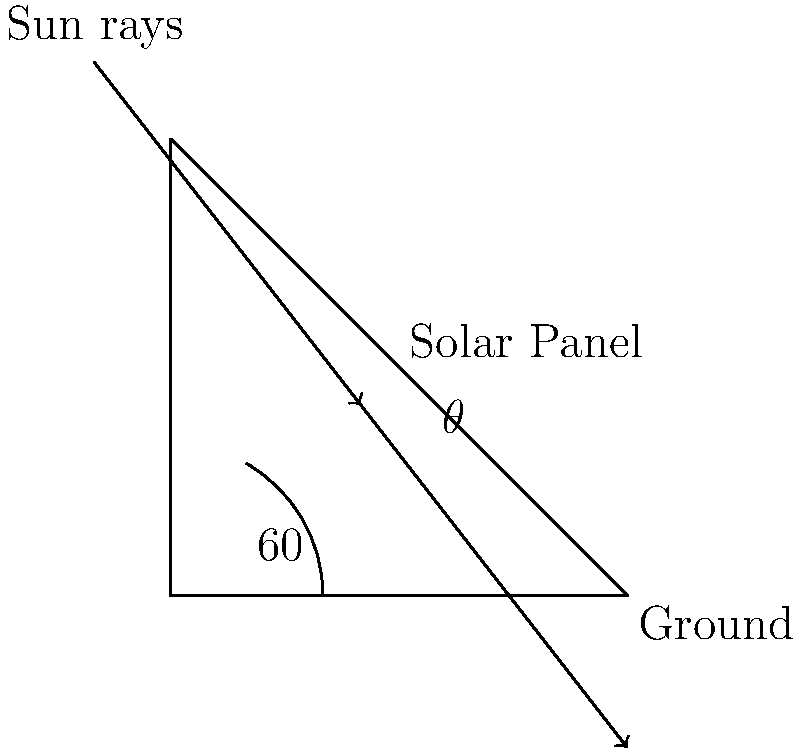In Tashkent, Uzbekistan, the average solar elevation angle during peak sunlight hours is approximately 60°. To maximize energy efficiency, solar panels should be installed perpendicular to the sun's rays. What angle $\theta$ should the solar panels be tilted from the horizontal to achieve optimal energy collection? Let's approach this step-by-step:

1) The sun's rays are coming in at a 60° angle from the horizontal.

2) For optimal energy collection, the solar panels should be perpendicular (at a 90° angle) to these rays.

3) We can use the fact that the sum of angles in a triangle is 180°.

4) In the triangle formed by the ground, the solar panel, and the sun's rays:
   - The angle between the ground and the sun's rays is 60°
   - The angle between the sun's rays and the solar panel should be 90° (perpendicular)
   - Let the angle we're looking for (between the ground and the solar panel) be $\theta$

5) Therefore, we can set up the equation:
   
   $60° + 90° + \theta = 180°$

6) Simplifying:
   
   $150° + \theta = 180°$

7) Solving for $\theta$:
   
   $\theta = 180° - 150° = 30°$

Thus, the solar panels should be tilted 30° from the horizontal.
Answer: 30° 